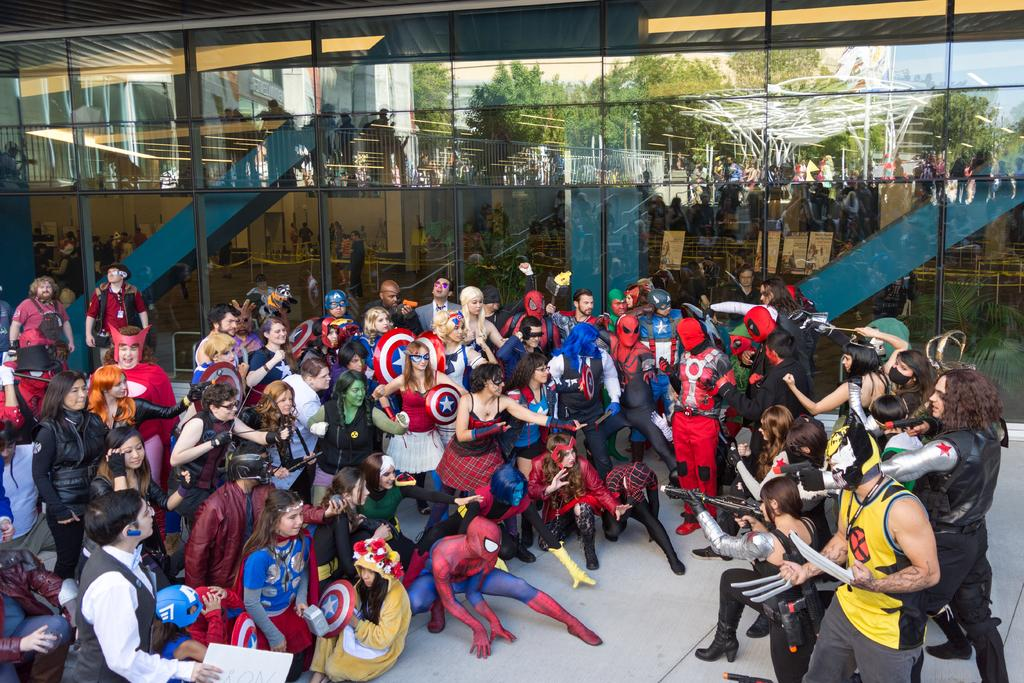What are the people in the image wearing? The people in the image are wearing different costumes. What can be seen inside the glass object in the image? People and a building are visible through the glass. What else can be seen through the glass in the image? Trees and the sky are also visible through the glass. What is the weather like outside the building in the image? The provided facts do not mention the weather, so it cannot be determined from the image. 